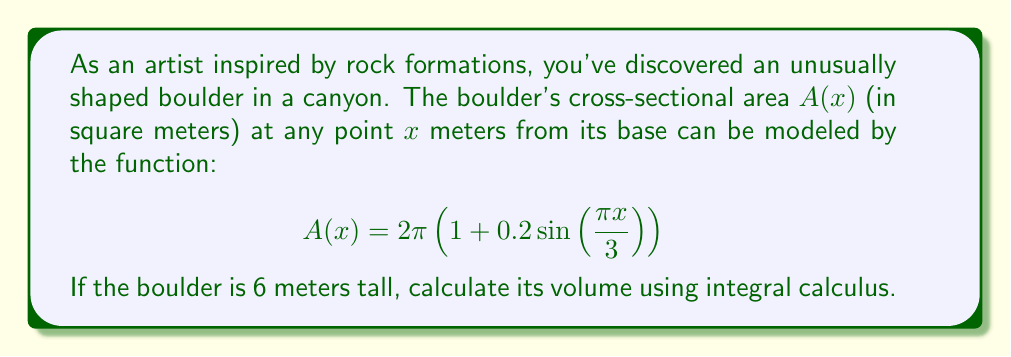Solve this math problem. To find the volume of this irregular rock formation, we need to use the concept of integration. The volume of a solid with known cross-sectional area function $A(x)$ over a height $h$ is given by:

$$V = \int_0^h A(x) dx$$

In this case, we have:
- Height (h) = 6 meters
- Cross-sectional area function: $A(x) = 2\pi\left(1 + 0.2\sin\left(\frac{\pi x}{3}\right)\right)$

Let's set up the integral:

$$V = \int_0^6 2\pi\left(1 + 0.2\sin\left(\frac{\pi x}{3}\right)\right) dx$$

To solve this, we can split the integral:

$$V = 2\pi\int_0^6 dx + 2\pi\int_0^6 0.2\sin\left(\frac{\pi x}{3}\right) dx$$

The first integral is straightforward:

$$2\pi\int_0^6 dx = 2\pi[x]_0^6 = 2\pi(6-0) = 12\pi$$

For the second integral, we need to use u-substitution:
Let $u = \frac{\pi x}{3}$, then $du = \frac{\pi}{3}dx$ and $dx = \frac{3}{\pi}du$

When $x = 0$, $u = 0$
When $x = 6$, $u = 2\pi$

Now the second integral becomes:

$$2\pi\int_0^6 0.2\sin\left(\frac{\pi x}{3}\right) dx = 2\pi \cdot 0.2 \cdot \frac{3}{\pi}\int_0^{2\pi} \sin(u) du$$

$$= 1.2\left[-\cos(u)\right]_0^{2\pi} = 1.2[-\cos(2\pi) + \cos(0)] = 1.2(0) = 0$$

Adding the results of both integrals:

$$V = 12\pi + 0 = 12\pi$$

Therefore, the volume of the boulder is $12\pi$ cubic meters.
Answer: $12\pi$ cubic meters 